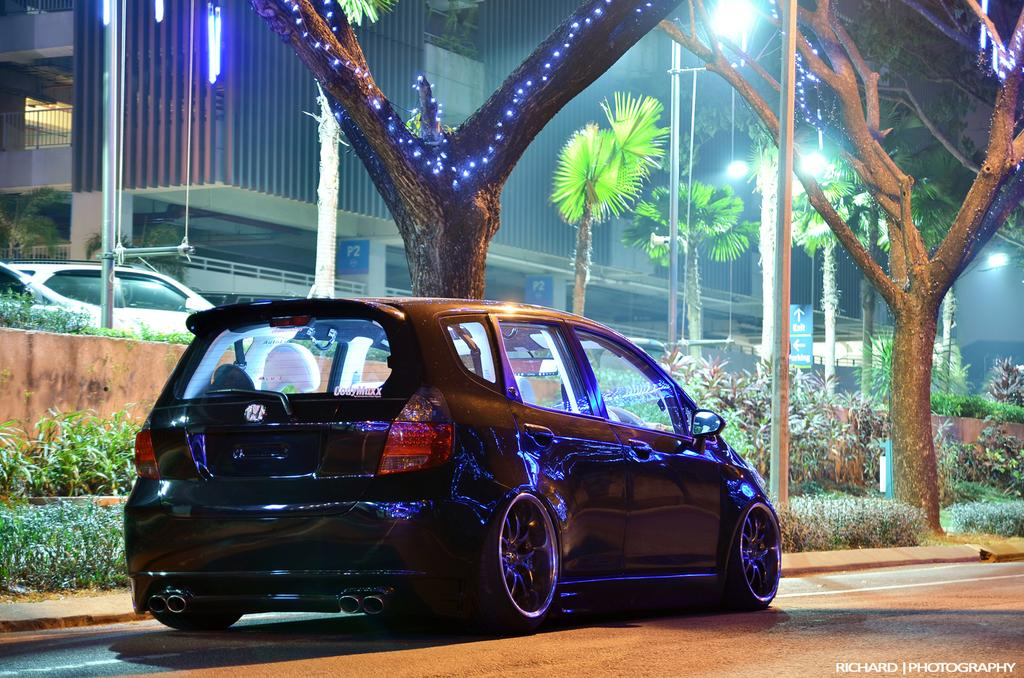What is the main subject in the foreground of the image? There is a car in the foreground of the image. What can be seen in the background of the image? There are trees, poles, street lights, plants, and buildings in the background of the image. Are there any other vehicles visible in the image? Yes, there is another vehicle in the background of the image. What type of berry is growing on the car in the image? There are no berries growing on the car in the image. How does the wind affect the car in the image? There is no indication of wind in the image, and therefore its effect on the car cannot be determined. 